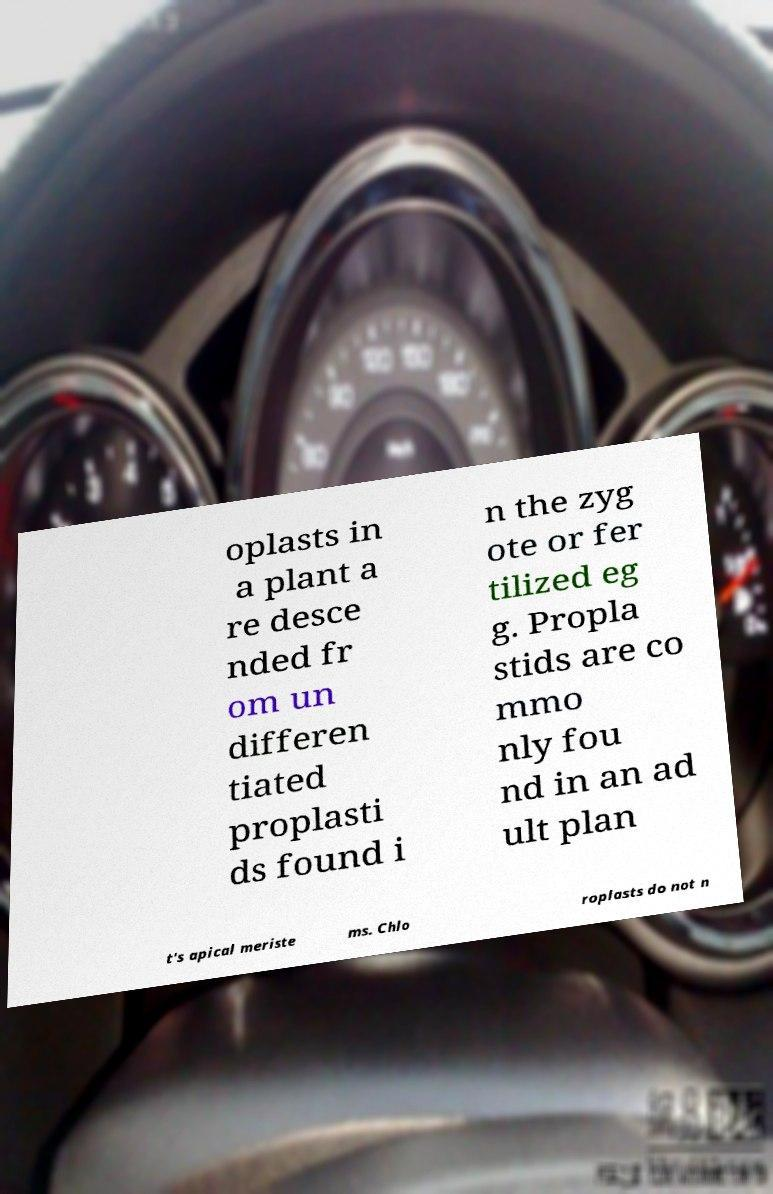Could you assist in decoding the text presented in this image and type it out clearly? oplasts in a plant a re desce nded fr om un differen tiated proplasti ds found i n the zyg ote or fer tilized eg g. Propla stids are co mmo nly fou nd in an ad ult plan t's apical meriste ms. Chlo roplasts do not n 